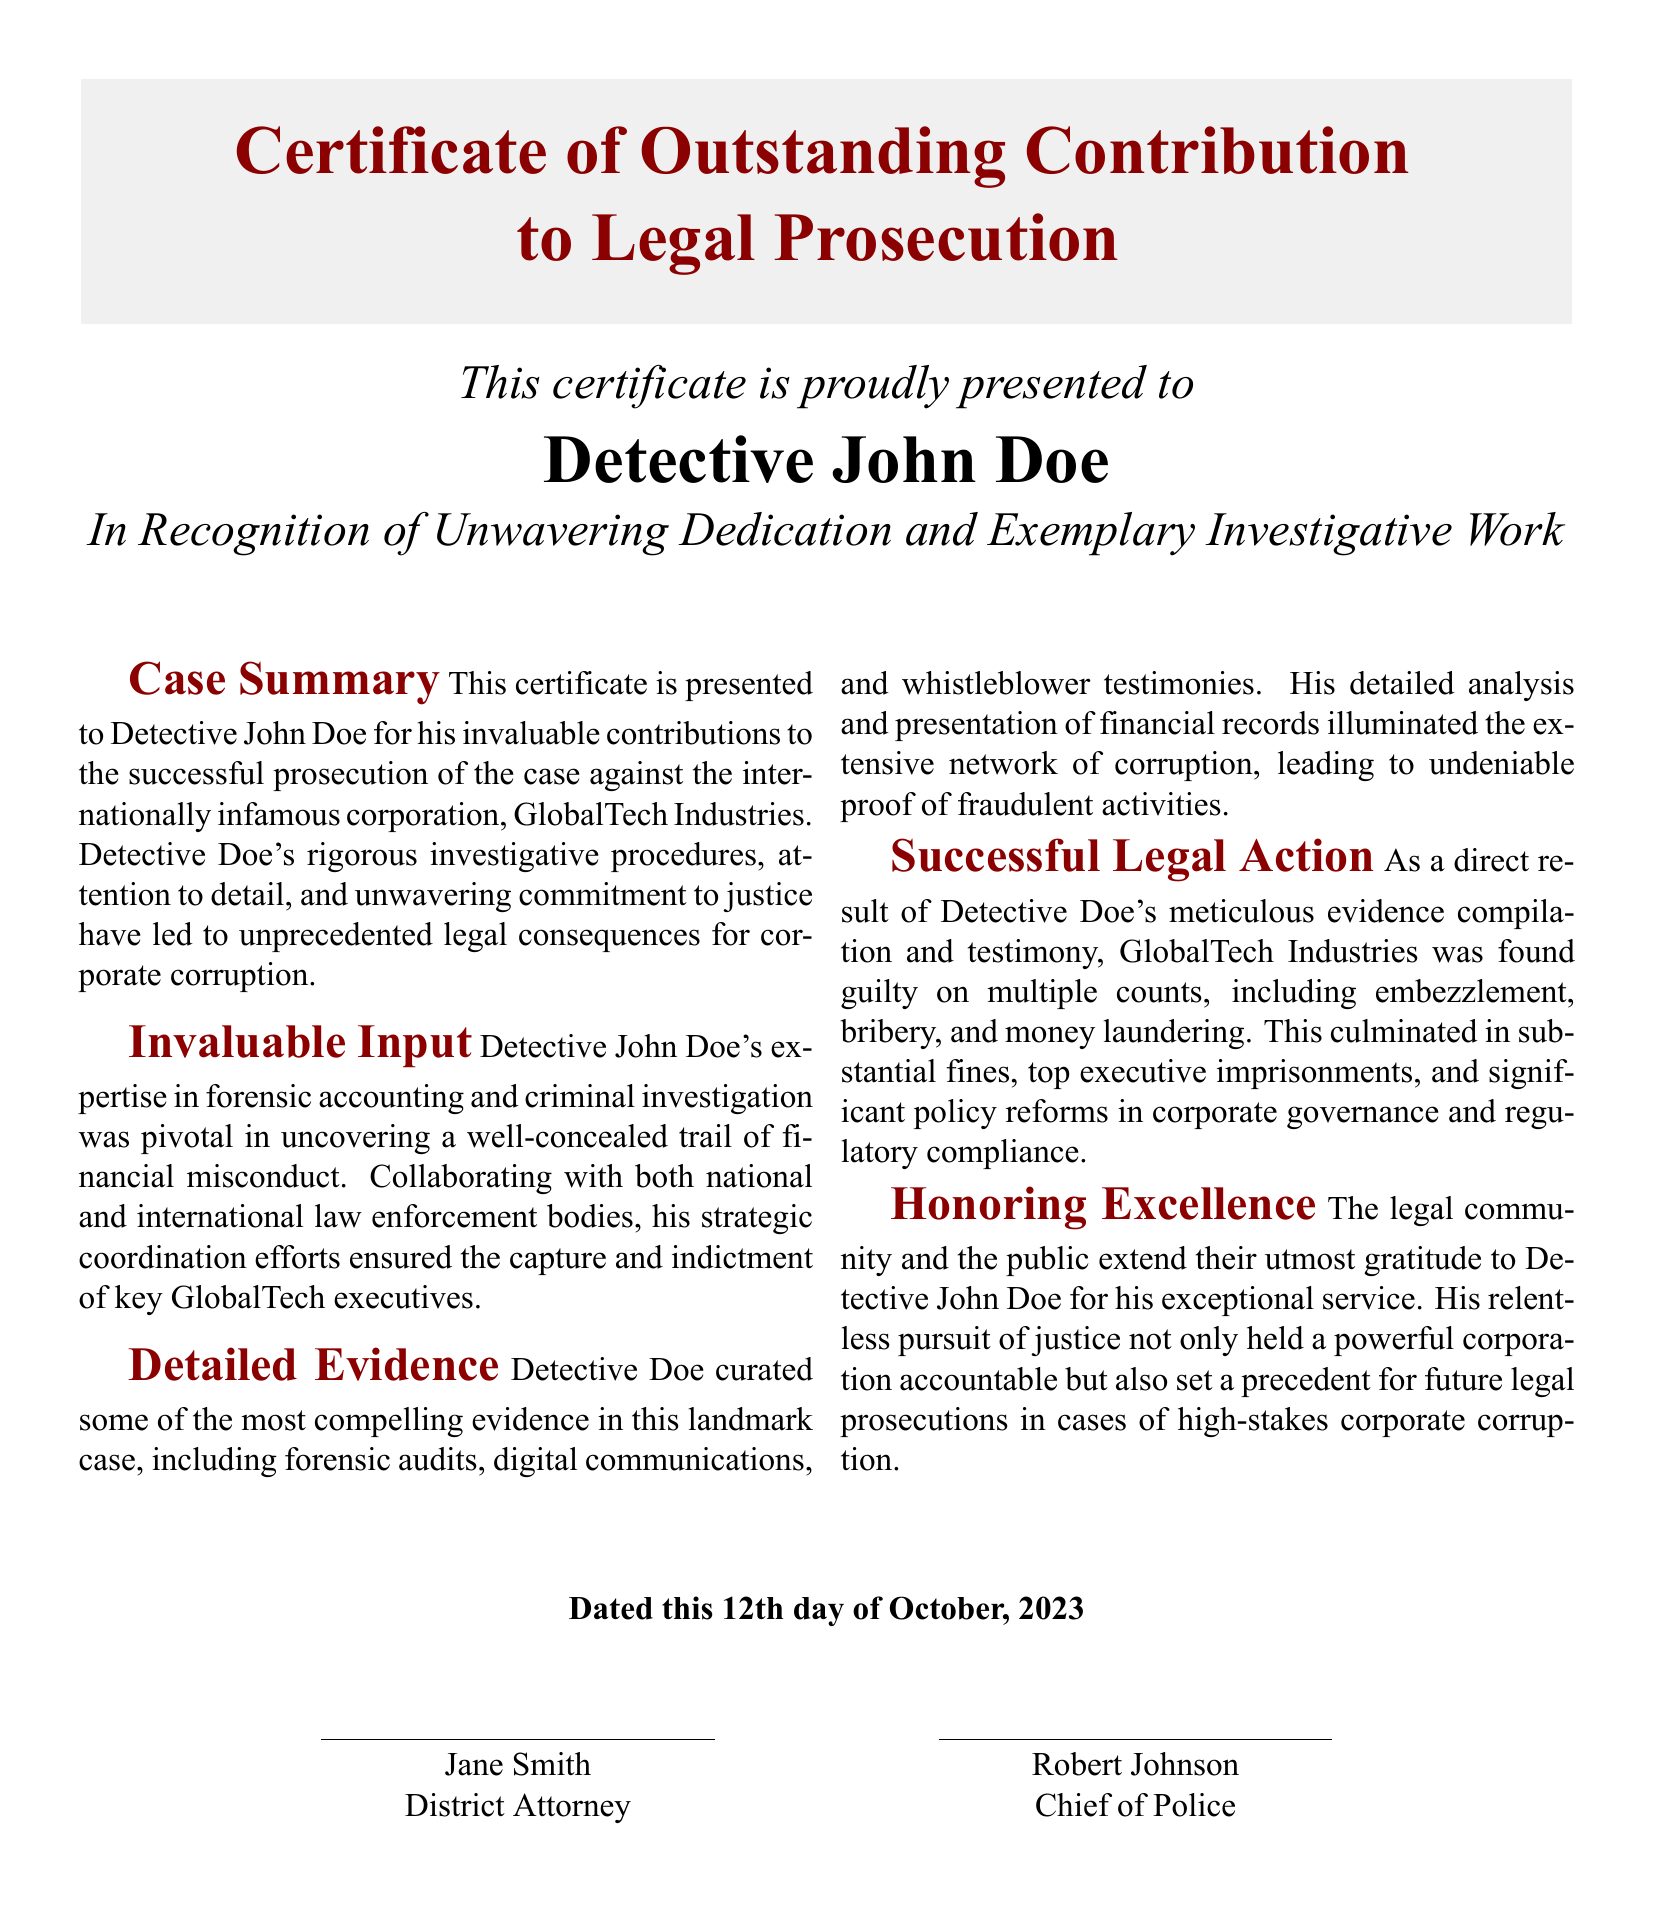What is the title of the certificate? The title of the certificate is stated at the top and signifies the achievement recognized, emphasizing outstanding contribution.
Answer: Certificate of Outstanding Contribution to Legal Prosecution Who is the recipient of the certificate? The recipient's name is prominently displayed to acknowledge their specific contribution to the case.
Answer: Detective John Doe What corporation was prosecuted? The corporation implicated in the case is identified in the summary, highlighting the target of legal action.
Answer: GlobalTech Industries What is the date of the certificate? The date is mentioned at the bottom of the document to indicate when the recognition was presented.
Answer: 12th day of October, 2023 What was a key area of expertise for Detective Doe? The document outlines Detective Doe's expertise, which was crucial for his investigative work and contributions.
Answer: Forensic accounting What type of misconduct was uncovered? The summary describes the nature of wrongdoing that was brought to light through the investigative efforts.
Answer: Financial misconduct How many areas of misconduct were GlobalTech Industries found guilty of? The document specifies different counts under which the corporation was prosecuted, indicating the severity of the legal actions.
Answer: Multiple counts Who are the signatories of the document? The names of the individuals who endorsed the certificate are mentioned at the end, indicating their roles in the recognition process.
Answer: Jane Smith and Robert Johnson What does the legal community express towards Detective Doe? The document captures the sentiment from the legal community regarding Detective Doe's efforts and contributions.
Answer: Utmost gratitude 